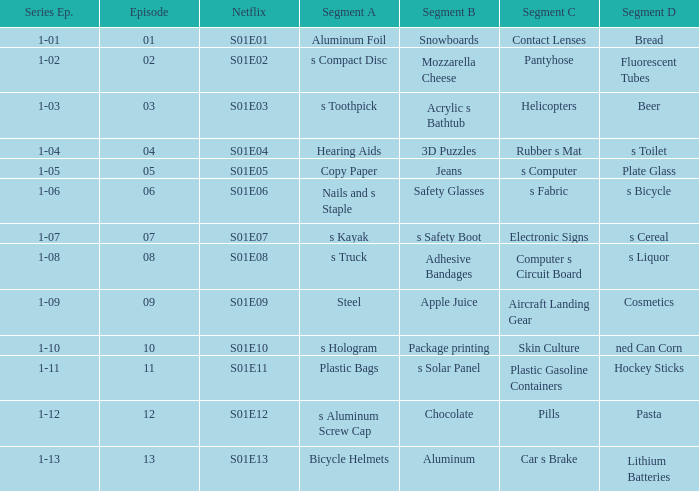What is the sequence number of the episode with a d segment and comprising luminescent tubes? 1-02. 